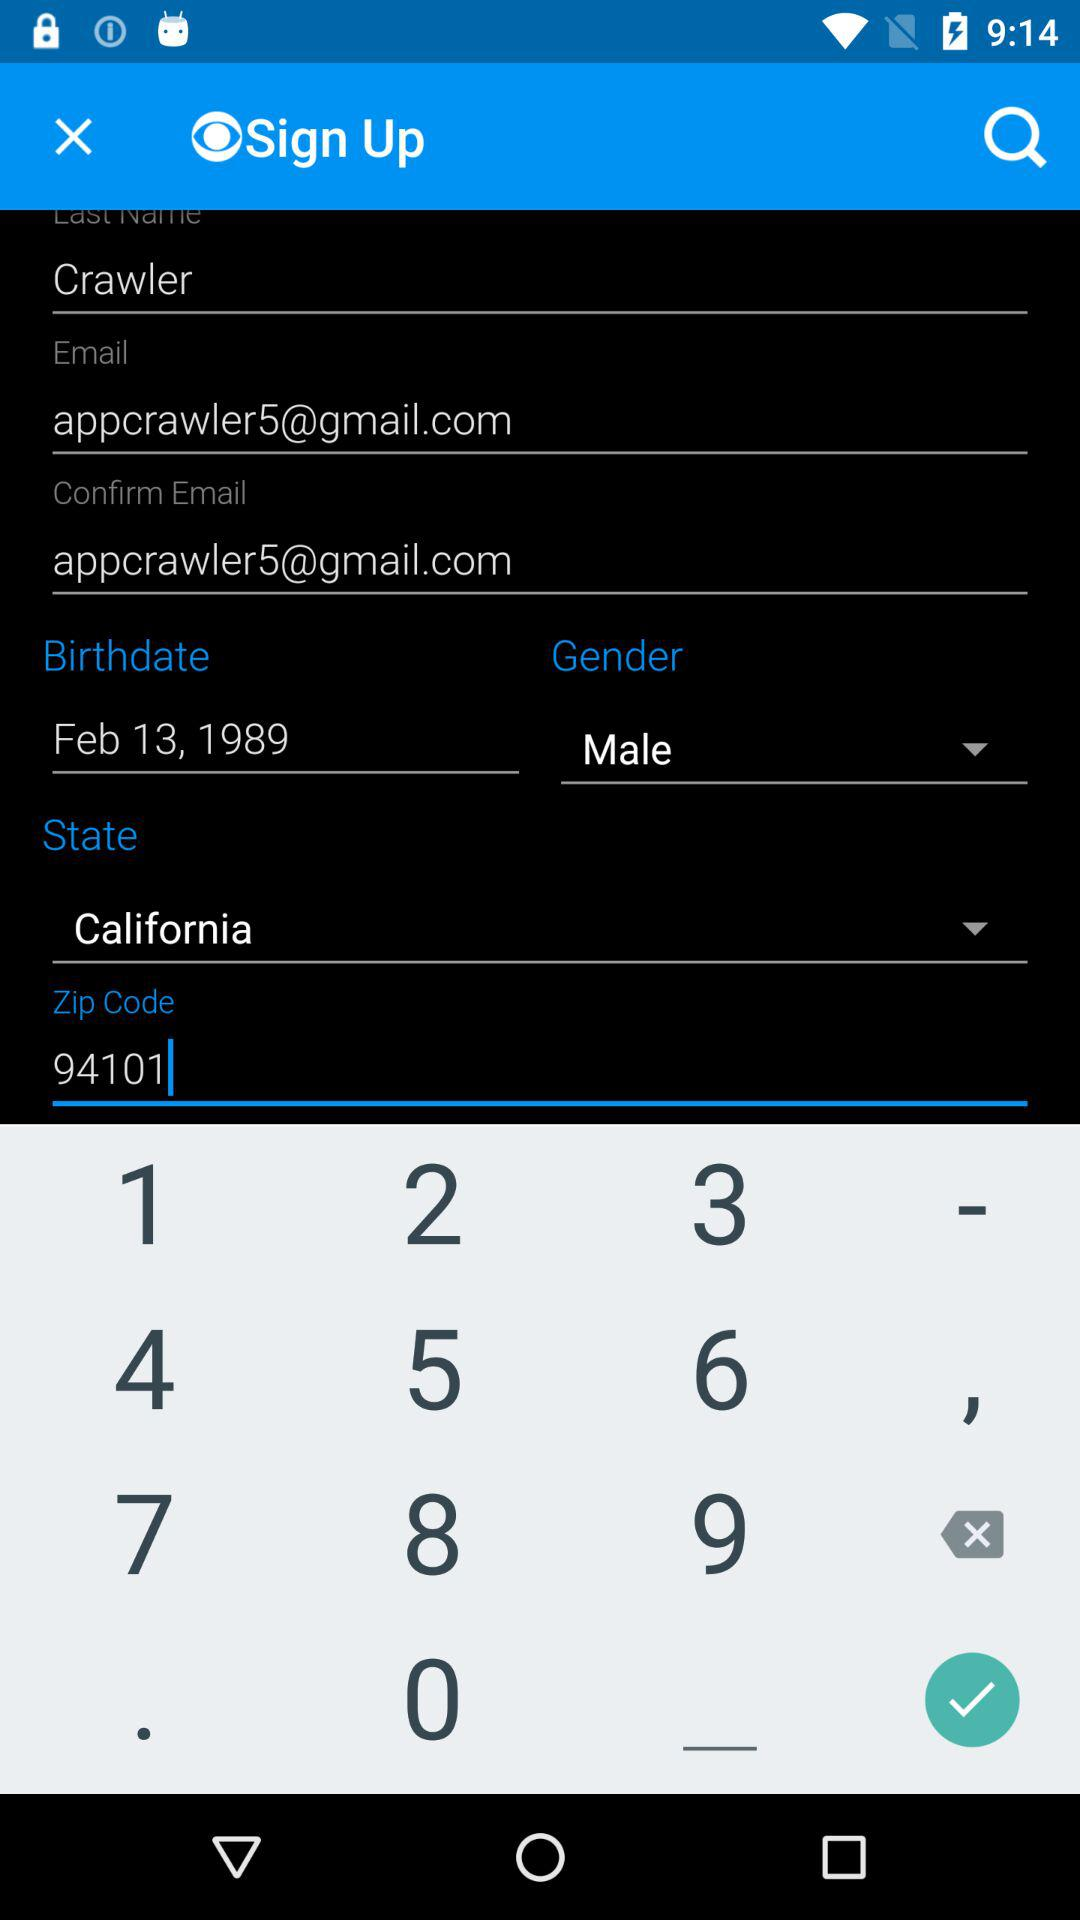How many stories are on CBS News?
When the provided information is insufficient, respond with <no answer>. <no answer> 